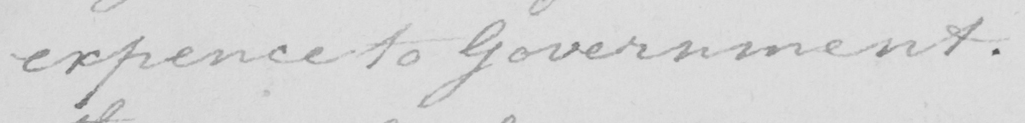What text is written in this handwritten line? expence to Government . 